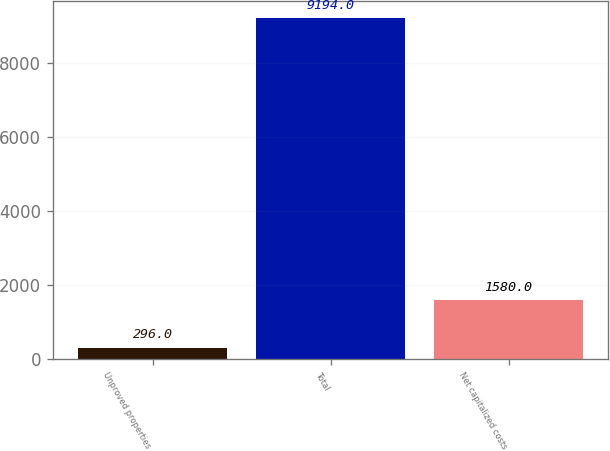Convert chart. <chart><loc_0><loc_0><loc_500><loc_500><bar_chart><fcel>Unproved properties<fcel>Total<fcel>Net capitalized costs<nl><fcel>296<fcel>9194<fcel>1580<nl></chart> 